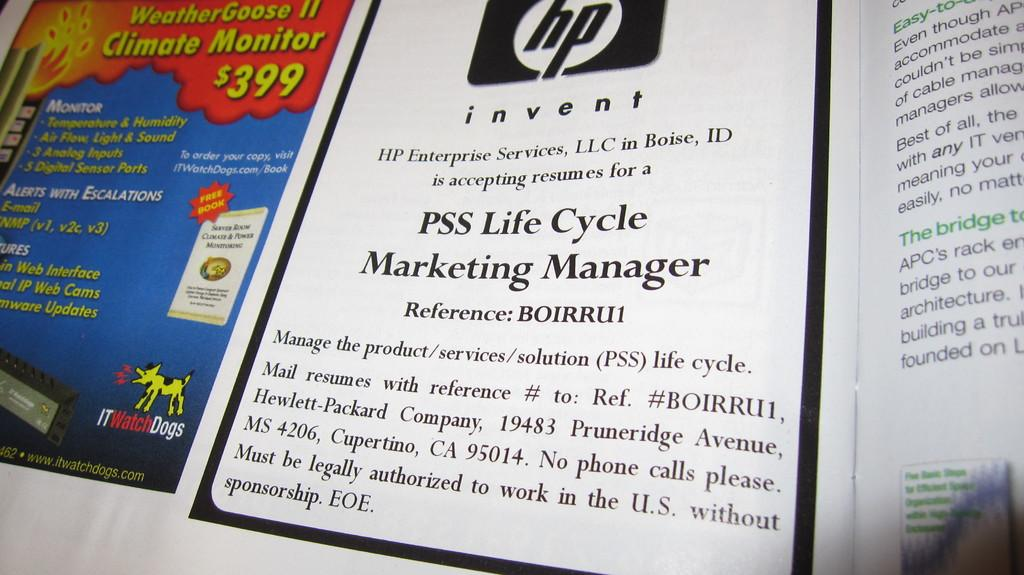<image>
Write a terse but informative summary of the picture. The hp logo is on the top of a page of a book that is opened. 